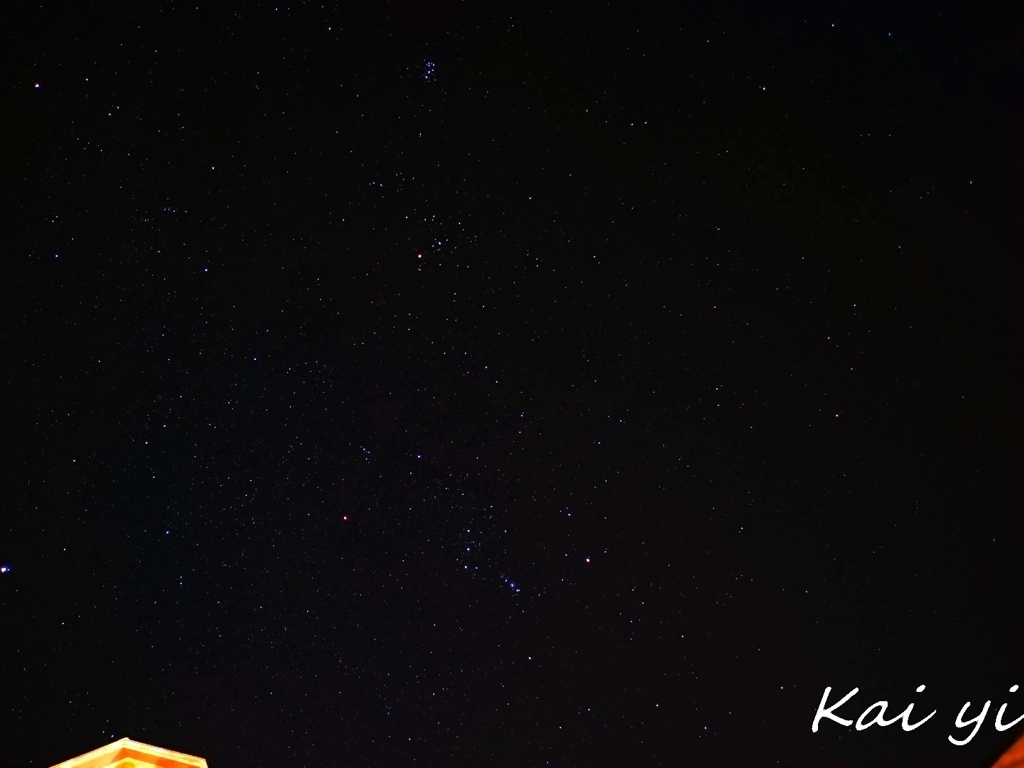What equipment or settings would improve the quality of night sky photos like this one? Improving night sky photos typically involves using a camera with a larger sensor to capture more light, lenses with a wide aperture such as f/2.8 or lower, and a tripod to support long exposure times without camera shake. Additionally, employing a higher ISO setting while avoiding too much noise and using manual focus to ensure sharpness of the stars can also enhance the result. Photographers often use specialized software to reduce noise and stack images for extra clarity. 